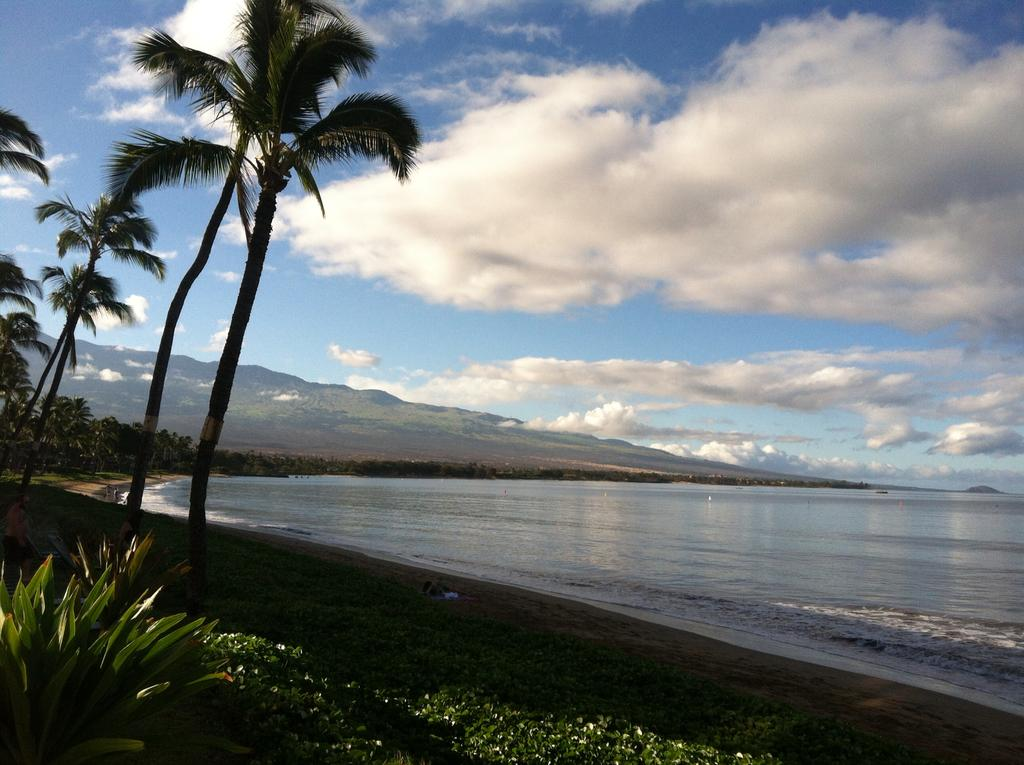What can be seen in the image that is not solid? There is water visible in the image. What type of vegetation is present at the side of the image? There are trees at the side of the image. What type of ground cover is present in the image? There is grass in the image. What other type of plant life is present in the image? There are plants in the image. What can be seen in the distance in the background of the image? There are mountains in the background of the image. What else is visible in the background of the image? The sky is visible in the background of the image. What type of card is being used to measure the depth of the water in the image? There is no card present in the image, and therefore no such activity can be observed. 